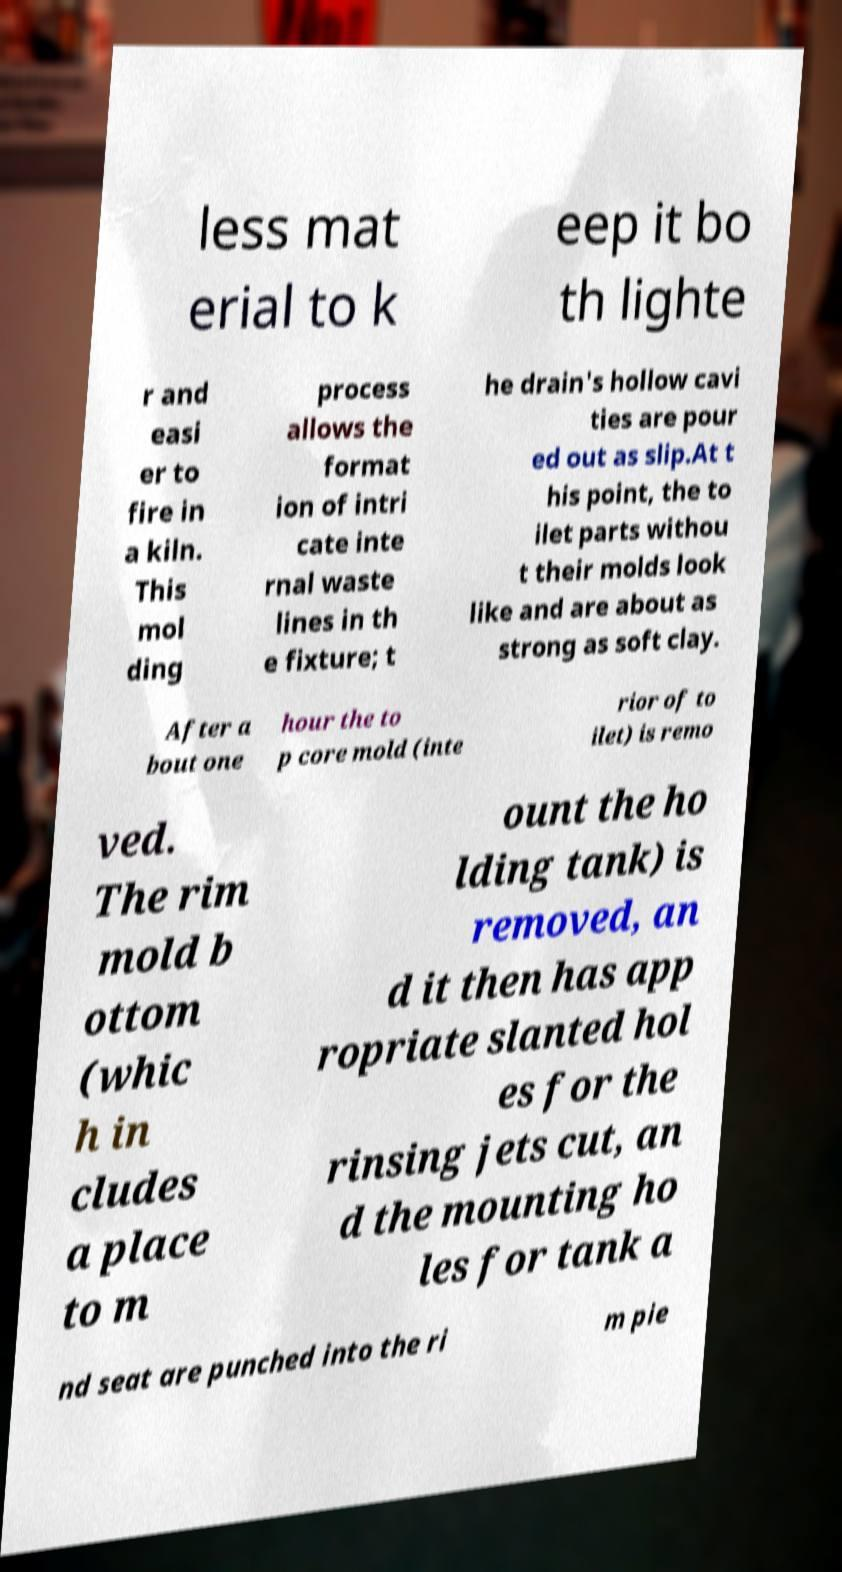I need the written content from this picture converted into text. Can you do that? less mat erial to k eep it bo th lighte r and easi er to fire in a kiln. This mol ding process allows the format ion of intri cate inte rnal waste lines in th e fixture; t he drain's hollow cavi ties are pour ed out as slip.At t his point, the to ilet parts withou t their molds look like and are about as strong as soft clay. After a bout one hour the to p core mold (inte rior of to ilet) is remo ved. The rim mold b ottom (whic h in cludes a place to m ount the ho lding tank) is removed, an d it then has app ropriate slanted hol es for the rinsing jets cut, an d the mounting ho les for tank a nd seat are punched into the ri m pie 